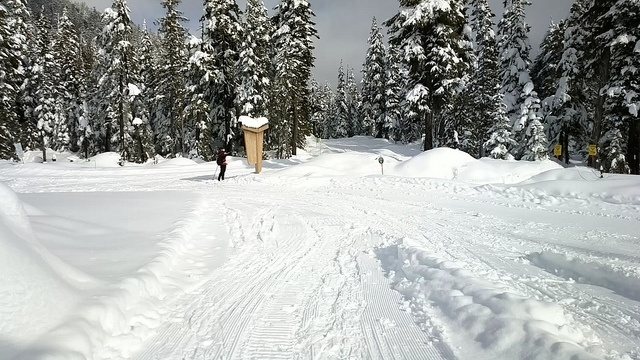Describe the objects in this image and their specific colors. I can see people in black, darkgray, white, and gray tones and snowboard in black, white, and lightgray tones in this image. 